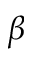<formula> <loc_0><loc_0><loc_500><loc_500>\beta</formula> 